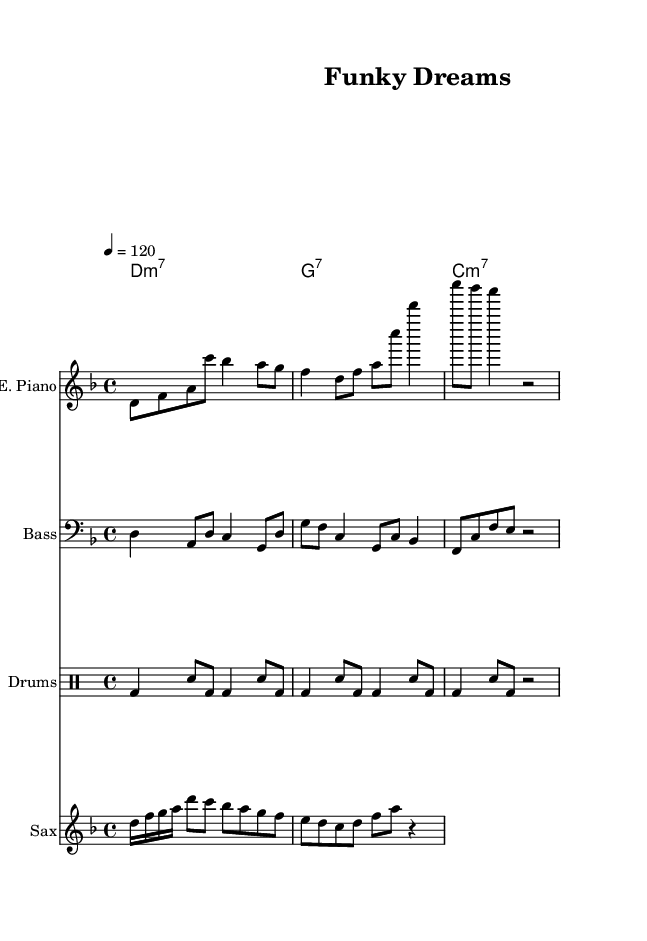What is the key signature of this music? The key signature is indicated by the absence of sharps or flats at the beginning of the staff, which points to D minor.
Answer: D minor What is the time signature of this piece? The time signature is found at the beginning of the staff, represented by 4/4, indicating four beats per measure.
Answer: 4/4 What is the tempo marking for this score? The tempo marking is indicated as “4 = 120," suggesting a moderate tempo with 120 beats per minute in quarter notes.
Answer: 120 How many measures are in the electric piano part? By counting the distinct sets of bars, we can determine there are four measures in the electric piano part.
Answer: 4 Which instruments play in this music? The sheet music lists four distinct instruments: Electric Piano, Bass, Drums, and Saxophone.
Answer: Electric Piano, Bass, Drums, Saxophone What type of chord follows the D minor seventh chord? The chord progression shown indicates that after the D minor seventh, there follows a G dominant seventh chord.
Answer: G7 What is the rest duration in the saxophone section? Looking closely at the saxophone part, there is a quarter rest notated after a series of notes, indicating silence for one quarter length.
Answer: r4 